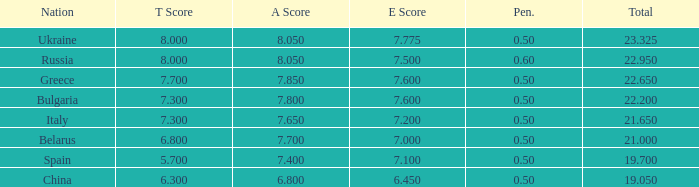95? None. 